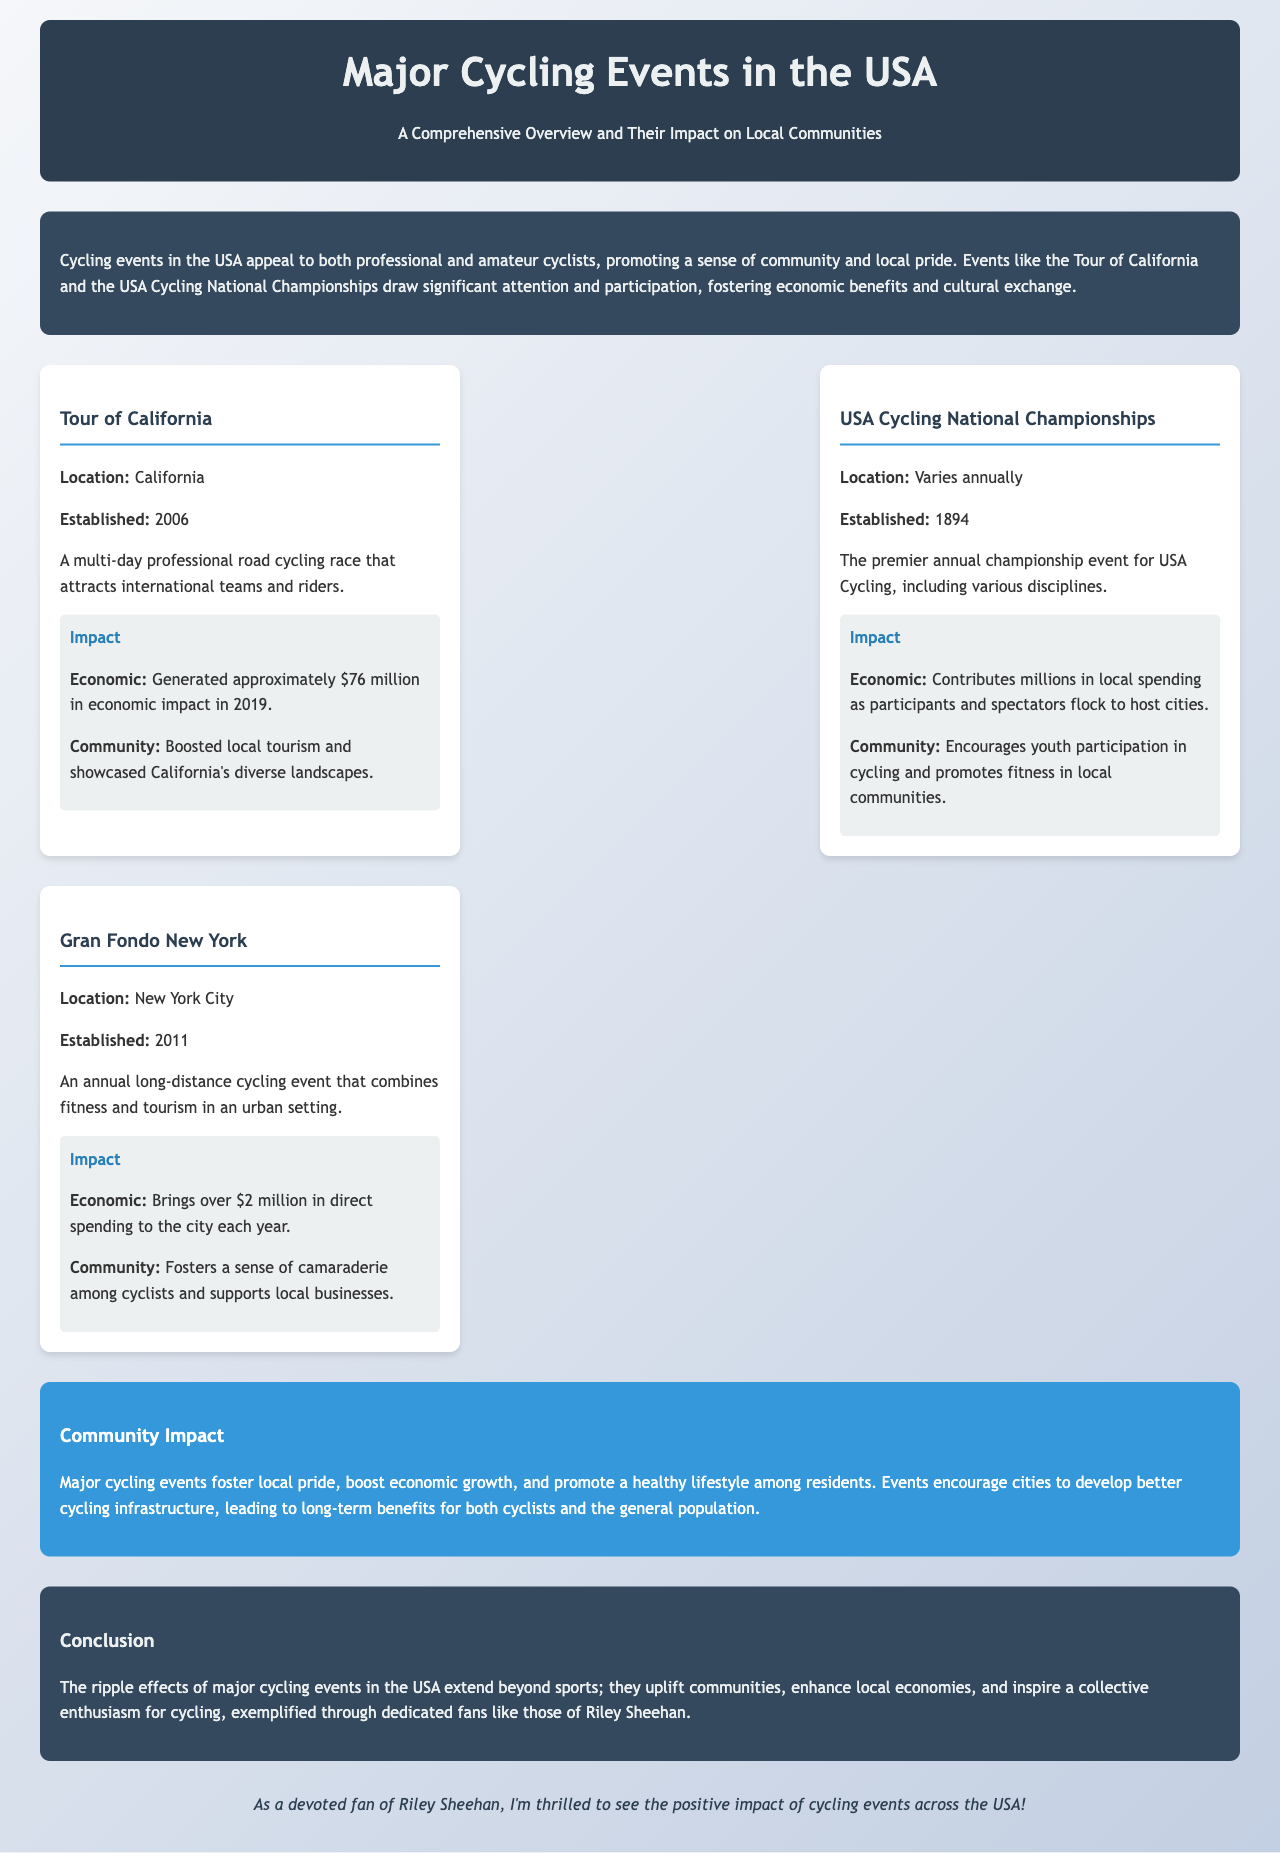What is the first cycling event listed? The first cycling event mentioned in the document is the "Tour of California."
Answer: Tour of California In what year was the USA Cycling National Championships established? The USA Cycling National Championships was established in 1894.
Answer: 1894 What was the economic impact of the Tour of California in 2019? The document states that the economic impact generated by the Tour of California in 2019 was approximately $76 million.
Answer: $76 million How much direct spending does Gran Fondo New York bring to the city each year? Gran Fondo New York brings over $2 million in direct spending to New York City each year.
Answer: over $2 million What key benefit do major cycling events bring to local communities? Major cycling events foster local pride, boost economic growth, and promote a healthy lifestyle among residents.
Answer: Local pride What is a major focus for cities hosting cycling events? The document highlights that hosting major cycling events encourages cities to develop better cycling infrastructure.
Answer: Better cycling infrastructure What kind of participants does the USA Cycling National Championships attract? The USA Cycling National Championships attracts participants from various cycling disciplines.
Answer: Various disciplines In what city does the Gran Fondo New York take place? The Gran Fondo New York event takes place in New York City.
Answer: New York City 